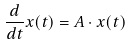<formula> <loc_0><loc_0><loc_500><loc_500>\frac { d } { d t } x ( t ) = A \cdot x ( t )</formula> 